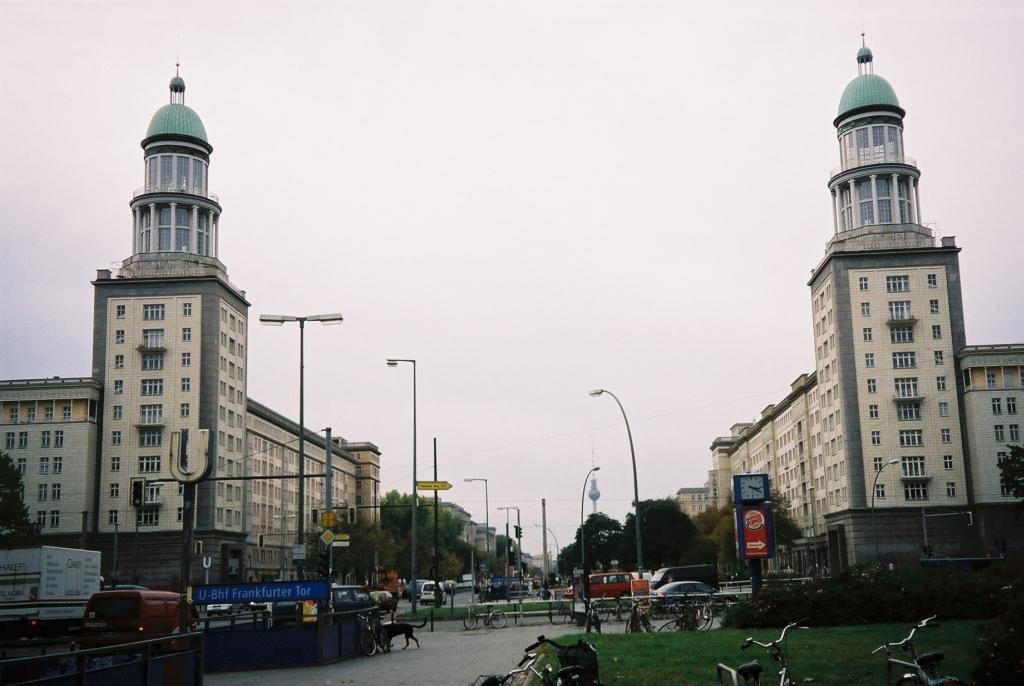What type of structures can be seen in the image? There are buildings in the image. What architectural features are present on the buildings? There are windows in the image. What type of lighting infrastructure is visible in the image? There are light poles in the image. What mode of transportation can be seen in the image? There are vehicles in the image. What type of signage is present in the image? There are sign boards in the image. What type of vegetation is present in the image? There are trees in the image. What time-telling device is present in the image? There is a clock in the image. What type of boards are present in the image? There are boards in the image. What type of traffic control devices are present in the image? There are traffic signals in the image. What type of personal transportation can be seen in the image? There are bicycles in the image. What is the color of the sky in the image? The sky is white in color. Can you tell me how many fish are being used as bait on the wall in the image? There are no fish or walls present in the image, and therefore no bait can be observed. 